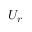Convert formula to latex. <formula><loc_0><loc_0><loc_500><loc_500>U _ { r }</formula> 